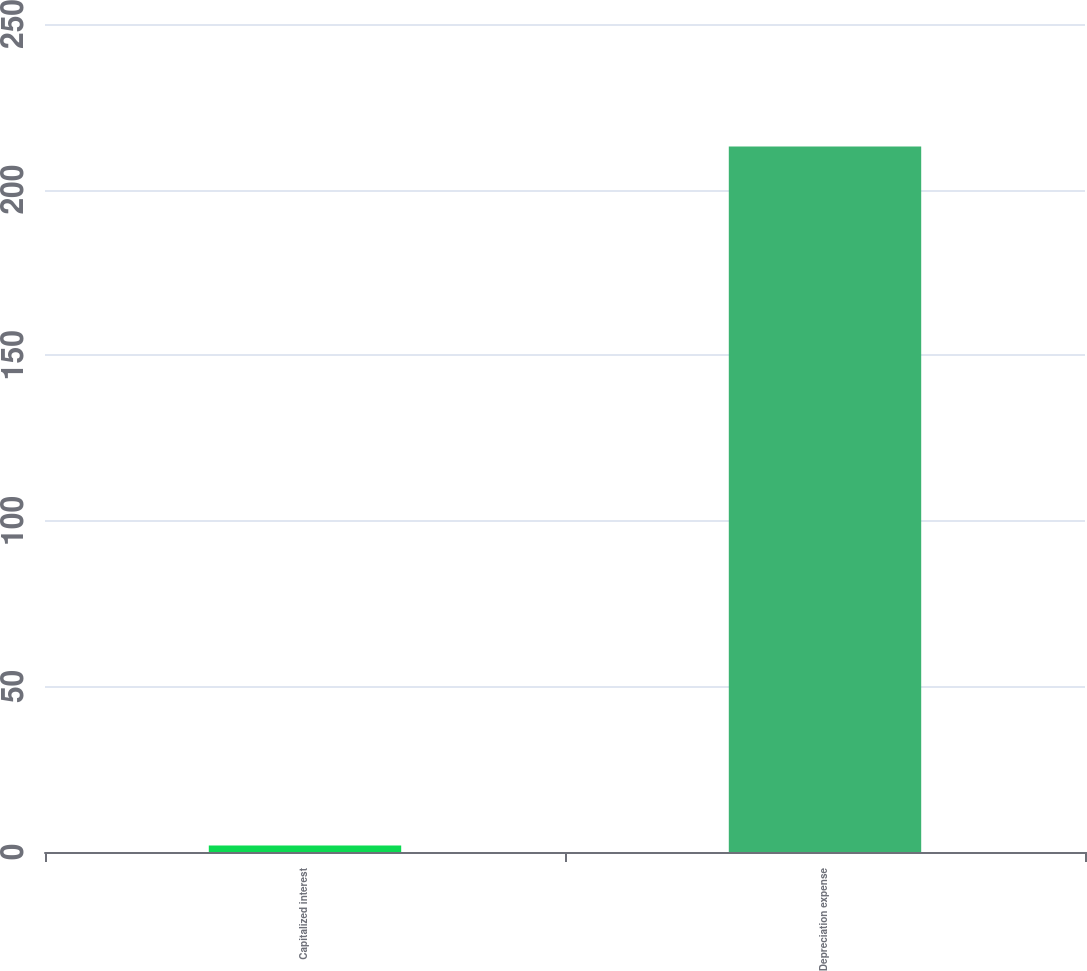Convert chart to OTSL. <chart><loc_0><loc_0><loc_500><loc_500><bar_chart><fcel>Capitalized interest<fcel>Depreciation expense<nl><fcel>2<fcel>213<nl></chart> 